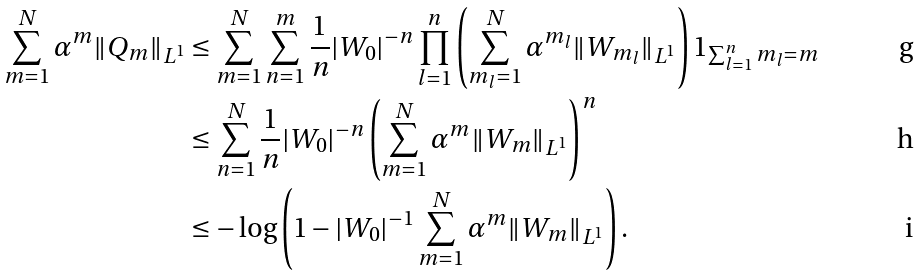<formula> <loc_0><loc_0><loc_500><loc_500>\sum _ { m = 1 } ^ { N } \alpha ^ { m } \| Q _ { m } \| _ { L ^ { 1 } } & \leq \sum _ { m = 1 } ^ { N } \sum _ { n = 1 } ^ { m } \frac { 1 } { n } | W _ { 0 } | ^ { - n } \prod _ { l = 1 } ^ { n } \left ( \sum _ { m _ { l } = 1 } ^ { N } \alpha ^ { m _ { l } } \| W _ { m _ { l } } \| _ { L ^ { 1 } } \right ) 1 _ { \sum _ { l = 1 } ^ { n } m _ { l } = m } \\ & \leq \sum _ { n = 1 } ^ { N } \frac { 1 } { n } | W _ { 0 } | ^ { - n } \left ( \sum _ { m = 1 } ^ { N } \alpha ^ { m } \| W _ { m } \| _ { L ^ { 1 } } \right ) ^ { n } \\ & \leq - \log \left ( 1 - | W _ { 0 } | ^ { - 1 } \sum _ { m = 1 } ^ { N } \alpha ^ { m } \| W _ { m } \| _ { L ^ { 1 } } \right ) .</formula> 